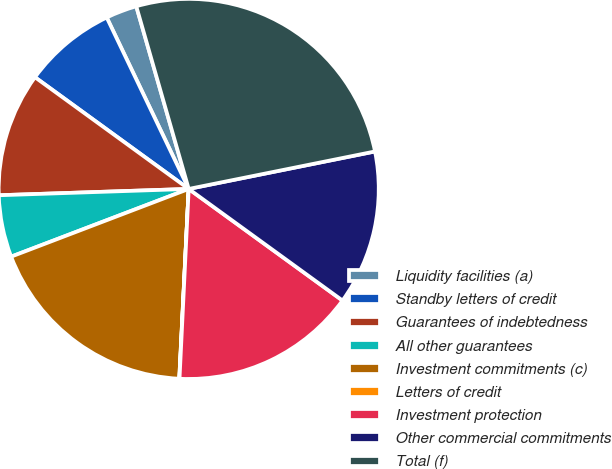<chart> <loc_0><loc_0><loc_500><loc_500><pie_chart><fcel>Liquidity facilities (a)<fcel>Standby letters of credit<fcel>Guarantees of indebtedness<fcel>All other guarantees<fcel>Investment commitments (c)<fcel>Letters of credit<fcel>Investment protection<fcel>Other commercial commitments<fcel>Total (f)<nl><fcel>2.65%<fcel>7.9%<fcel>10.53%<fcel>5.27%<fcel>18.41%<fcel>0.02%<fcel>15.78%<fcel>13.15%<fcel>26.29%<nl></chart> 